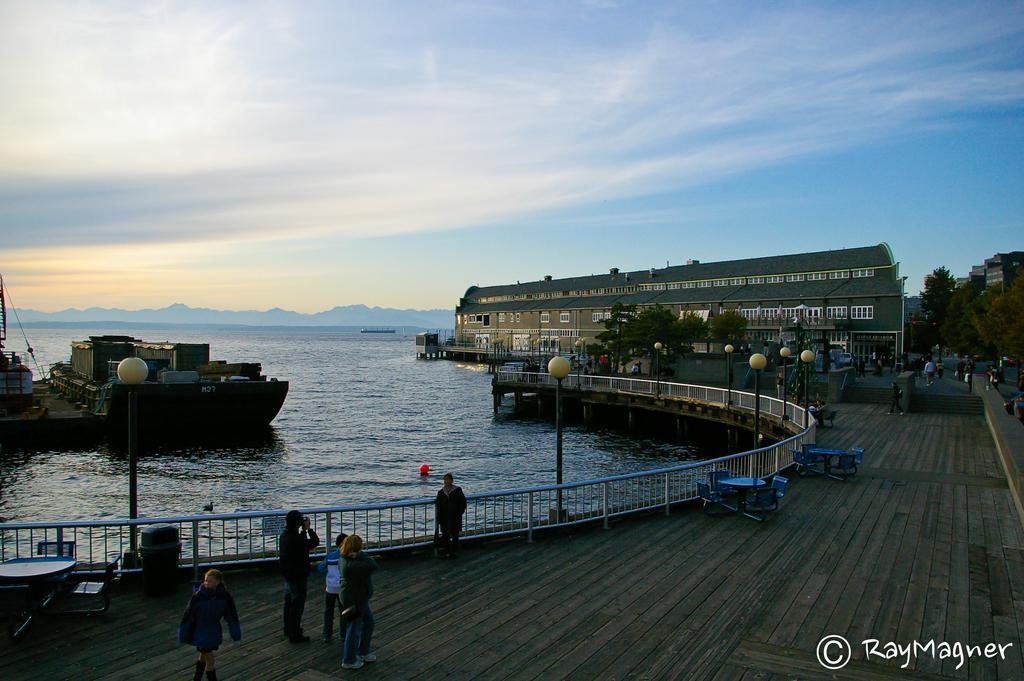Could you give a brief overview of what you see in this image? There are people and we can see chairs, tables, fence and lights on poles. We can see boat above the water. In the background we can see people, trees, buildings and sky. In the bottom right side of the image we can see text. 